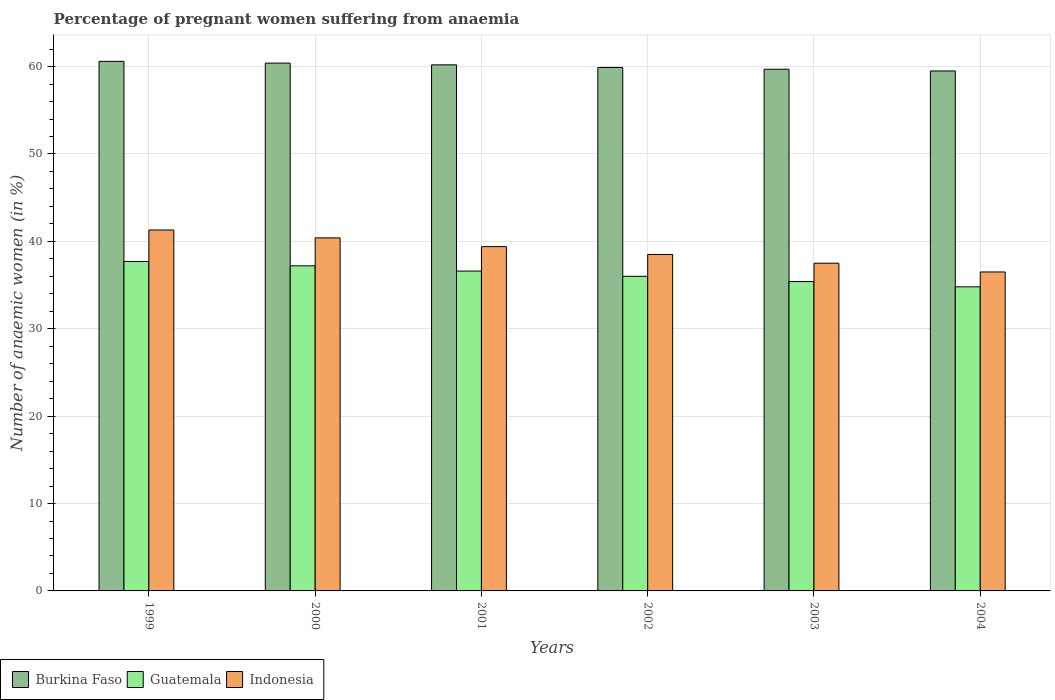Are the number of bars on each tick of the X-axis equal?
Your answer should be compact. Yes. How many bars are there on the 2nd tick from the left?
Offer a terse response. 3. How many bars are there on the 6th tick from the right?
Offer a terse response. 3. What is the number of anaemic women in Burkina Faso in 2000?
Offer a very short reply. 60.4. Across all years, what is the maximum number of anaemic women in Guatemala?
Ensure brevity in your answer.  37.7. Across all years, what is the minimum number of anaemic women in Indonesia?
Your answer should be compact. 36.5. What is the total number of anaemic women in Guatemala in the graph?
Provide a short and direct response. 217.7. What is the difference between the number of anaemic women in Burkina Faso in 2000 and that in 2003?
Provide a succinct answer. 0.7. What is the difference between the number of anaemic women in Indonesia in 2003 and the number of anaemic women in Guatemala in 2001?
Offer a very short reply. 0.9. What is the average number of anaemic women in Burkina Faso per year?
Your answer should be compact. 60.05. In the year 1999, what is the difference between the number of anaemic women in Guatemala and number of anaemic women in Indonesia?
Provide a succinct answer. -3.6. What is the ratio of the number of anaemic women in Guatemala in 1999 to that in 2004?
Your answer should be very brief. 1.08. What is the difference between the highest and the second highest number of anaemic women in Burkina Faso?
Your answer should be very brief. 0.2. What is the difference between the highest and the lowest number of anaemic women in Burkina Faso?
Your answer should be very brief. 1.1. Is the sum of the number of anaemic women in Burkina Faso in 1999 and 2004 greater than the maximum number of anaemic women in Guatemala across all years?
Your answer should be compact. Yes. What does the 2nd bar from the right in 2004 represents?
Your answer should be very brief. Guatemala. Does the graph contain any zero values?
Your answer should be very brief. No. Where does the legend appear in the graph?
Your response must be concise. Bottom left. What is the title of the graph?
Keep it short and to the point. Percentage of pregnant women suffering from anaemia. Does "Syrian Arab Republic" appear as one of the legend labels in the graph?
Provide a short and direct response. No. What is the label or title of the X-axis?
Your answer should be very brief. Years. What is the label or title of the Y-axis?
Offer a terse response. Number of anaemic women (in %). What is the Number of anaemic women (in %) of Burkina Faso in 1999?
Your response must be concise. 60.6. What is the Number of anaemic women (in %) of Guatemala in 1999?
Your answer should be very brief. 37.7. What is the Number of anaemic women (in %) of Indonesia in 1999?
Your answer should be compact. 41.3. What is the Number of anaemic women (in %) of Burkina Faso in 2000?
Your answer should be compact. 60.4. What is the Number of anaemic women (in %) in Guatemala in 2000?
Provide a short and direct response. 37.2. What is the Number of anaemic women (in %) of Indonesia in 2000?
Your response must be concise. 40.4. What is the Number of anaemic women (in %) in Burkina Faso in 2001?
Offer a very short reply. 60.2. What is the Number of anaemic women (in %) of Guatemala in 2001?
Provide a succinct answer. 36.6. What is the Number of anaemic women (in %) in Indonesia in 2001?
Your response must be concise. 39.4. What is the Number of anaemic women (in %) in Burkina Faso in 2002?
Offer a very short reply. 59.9. What is the Number of anaemic women (in %) in Guatemala in 2002?
Keep it short and to the point. 36. What is the Number of anaemic women (in %) of Indonesia in 2002?
Give a very brief answer. 38.5. What is the Number of anaemic women (in %) in Burkina Faso in 2003?
Your answer should be very brief. 59.7. What is the Number of anaemic women (in %) of Guatemala in 2003?
Provide a short and direct response. 35.4. What is the Number of anaemic women (in %) in Indonesia in 2003?
Your answer should be very brief. 37.5. What is the Number of anaemic women (in %) of Burkina Faso in 2004?
Your response must be concise. 59.5. What is the Number of anaemic women (in %) in Guatemala in 2004?
Make the answer very short. 34.8. What is the Number of anaemic women (in %) of Indonesia in 2004?
Your answer should be compact. 36.5. Across all years, what is the maximum Number of anaemic women (in %) of Burkina Faso?
Keep it short and to the point. 60.6. Across all years, what is the maximum Number of anaemic women (in %) of Guatemala?
Ensure brevity in your answer.  37.7. Across all years, what is the maximum Number of anaemic women (in %) of Indonesia?
Provide a short and direct response. 41.3. Across all years, what is the minimum Number of anaemic women (in %) of Burkina Faso?
Provide a succinct answer. 59.5. Across all years, what is the minimum Number of anaemic women (in %) in Guatemala?
Offer a terse response. 34.8. Across all years, what is the minimum Number of anaemic women (in %) of Indonesia?
Your answer should be very brief. 36.5. What is the total Number of anaemic women (in %) in Burkina Faso in the graph?
Give a very brief answer. 360.3. What is the total Number of anaemic women (in %) of Guatemala in the graph?
Your answer should be compact. 217.7. What is the total Number of anaemic women (in %) of Indonesia in the graph?
Your answer should be compact. 233.6. What is the difference between the Number of anaemic women (in %) in Burkina Faso in 1999 and that in 2000?
Give a very brief answer. 0.2. What is the difference between the Number of anaemic women (in %) of Indonesia in 1999 and that in 2000?
Make the answer very short. 0.9. What is the difference between the Number of anaemic women (in %) of Burkina Faso in 1999 and that in 2001?
Offer a terse response. 0.4. What is the difference between the Number of anaemic women (in %) of Indonesia in 1999 and that in 2001?
Make the answer very short. 1.9. What is the difference between the Number of anaemic women (in %) in Burkina Faso in 1999 and that in 2002?
Your answer should be very brief. 0.7. What is the difference between the Number of anaemic women (in %) in Guatemala in 1999 and that in 2002?
Provide a succinct answer. 1.7. What is the difference between the Number of anaemic women (in %) of Burkina Faso in 1999 and that in 2003?
Give a very brief answer. 0.9. What is the difference between the Number of anaemic women (in %) in Guatemala in 1999 and that in 2003?
Keep it short and to the point. 2.3. What is the difference between the Number of anaemic women (in %) in Indonesia in 1999 and that in 2003?
Provide a short and direct response. 3.8. What is the difference between the Number of anaemic women (in %) of Indonesia in 1999 and that in 2004?
Ensure brevity in your answer.  4.8. What is the difference between the Number of anaemic women (in %) in Burkina Faso in 2000 and that in 2001?
Give a very brief answer. 0.2. What is the difference between the Number of anaemic women (in %) in Burkina Faso in 2000 and that in 2002?
Offer a terse response. 0.5. What is the difference between the Number of anaemic women (in %) of Guatemala in 2000 and that in 2002?
Ensure brevity in your answer.  1.2. What is the difference between the Number of anaemic women (in %) in Burkina Faso in 2000 and that in 2003?
Provide a succinct answer. 0.7. What is the difference between the Number of anaemic women (in %) in Burkina Faso in 2000 and that in 2004?
Provide a short and direct response. 0.9. What is the difference between the Number of anaemic women (in %) of Guatemala in 2001 and that in 2002?
Your response must be concise. 0.6. What is the difference between the Number of anaemic women (in %) in Indonesia in 2001 and that in 2003?
Offer a terse response. 1.9. What is the difference between the Number of anaemic women (in %) of Guatemala in 2001 and that in 2004?
Provide a succinct answer. 1.8. What is the difference between the Number of anaemic women (in %) in Burkina Faso in 2002 and that in 2003?
Provide a succinct answer. 0.2. What is the difference between the Number of anaemic women (in %) of Indonesia in 2002 and that in 2003?
Your answer should be very brief. 1. What is the difference between the Number of anaemic women (in %) of Burkina Faso in 2002 and that in 2004?
Ensure brevity in your answer.  0.4. What is the difference between the Number of anaemic women (in %) in Burkina Faso in 2003 and that in 2004?
Keep it short and to the point. 0.2. What is the difference between the Number of anaemic women (in %) in Guatemala in 2003 and that in 2004?
Give a very brief answer. 0.6. What is the difference between the Number of anaemic women (in %) of Indonesia in 2003 and that in 2004?
Keep it short and to the point. 1. What is the difference between the Number of anaemic women (in %) in Burkina Faso in 1999 and the Number of anaemic women (in %) in Guatemala in 2000?
Provide a short and direct response. 23.4. What is the difference between the Number of anaemic women (in %) of Burkina Faso in 1999 and the Number of anaemic women (in %) of Indonesia in 2000?
Keep it short and to the point. 20.2. What is the difference between the Number of anaemic women (in %) in Burkina Faso in 1999 and the Number of anaemic women (in %) in Guatemala in 2001?
Ensure brevity in your answer.  24. What is the difference between the Number of anaemic women (in %) in Burkina Faso in 1999 and the Number of anaemic women (in %) in Indonesia in 2001?
Offer a very short reply. 21.2. What is the difference between the Number of anaemic women (in %) in Burkina Faso in 1999 and the Number of anaemic women (in %) in Guatemala in 2002?
Offer a terse response. 24.6. What is the difference between the Number of anaemic women (in %) of Burkina Faso in 1999 and the Number of anaemic women (in %) of Indonesia in 2002?
Your answer should be very brief. 22.1. What is the difference between the Number of anaemic women (in %) of Guatemala in 1999 and the Number of anaemic women (in %) of Indonesia in 2002?
Ensure brevity in your answer.  -0.8. What is the difference between the Number of anaemic women (in %) in Burkina Faso in 1999 and the Number of anaemic women (in %) in Guatemala in 2003?
Ensure brevity in your answer.  25.2. What is the difference between the Number of anaemic women (in %) in Burkina Faso in 1999 and the Number of anaemic women (in %) in Indonesia in 2003?
Your answer should be compact. 23.1. What is the difference between the Number of anaemic women (in %) of Burkina Faso in 1999 and the Number of anaemic women (in %) of Guatemala in 2004?
Offer a terse response. 25.8. What is the difference between the Number of anaemic women (in %) of Burkina Faso in 1999 and the Number of anaemic women (in %) of Indonesia in 2004?
Ensure brevity in your answer.  24.1. What is the difference between the Number of anaemic women (in %) in Burkina Faso in 2000 and the Number of anaemic women (in %) in Guatemala in 2001?
Your answer should be compact. 23.8. What is the difference between the Number of anaemic women (in %) of Guatemala in 2000 and the Number of anaemic women (in %) of Indonesia in 2001?
Provide a succinct answer. -2.2. What is the difference between the Number of anaemic women (in %) of Burkina Faso in 2000 and the Number of anaemic women (in %) of Guatemala in 2002?
Make the answer very short. 24.4. What is the difference between the Number of anaemic women (in %) in Burkina Faso in 2000 and the Number of anaemic women (in %) in Indonesia in 2002?
Offer a very short reply. 21.9. What is the difference between the Number of anaemic women (in %) in Guatemala in 2000 and the Number of anaemic women (in %) in Indonesia in 2002?
Make the answer very short. -1.3. What is the difference between the Number of anaemic women (in %) in Burkina Faso in 2000 and the Number of anaemic women (in %) in Indonesia in 2003?
Give a very brief answer. 22.9. What is the difference between the Number of anaemic women (in %) in Guatemala in 2000 and the Number of anaemic women (in %) in Indonesia in 2003?
Your response must be concise. -0.3. What is the difference between the Number of anaemic women (in %) of Burkina Faso in 2000 and the Number of anaemic women (in %) of Guatemala in 2004?
Provide a short and direct response. 25.6. What is the difference between the Number of anaemic women (in %) in Burkina Faso in 2000 and the Number of anaemic women (in %) in Indonesia in 2004?
Provide a short and direct response. 23.9. What is the difference between the Number of anaemic women (in %) of Guatemala in 2000 and the Number of anaemic women (in %) of Indonesia in 2004?
Your response must be concise. 0.7. What is the difference between the Number of anaemic women (in %) of Burkina Faso in 2001 and the Number of anaemic women (in %) of Guatemala in 2002?
Your answer should be compact. 24.2. What is the difference between the Number of anaemic women (in %) in Burkina Faso in 2001 and the Number of anaemic women (in %) in Indonesia in 2002?
Your answer should be compact. 21.7. What is the difference between the Number of anaemic women (in %) of Guatemala in 2001 and the Number of anaemic women (in %) of Indonesia in 2002?
Make the answer very short. -1.9. What is the difference between the Number of anaemic women (in %) of Burkina Faso in 2001 and the Number of anaemic women (in %) of Guatemala in 2003?
Your answer should be very brief. 24.8. What is the difference between the Number of anaemic women (in %) in Burkina Faso in 2001 and the Number of anaemic women (in %) in Indonesia in 2003?
Provide a succinct answer. 22.7. What is the difference between the Number of anaemic women (in %) of Burkina Faso in 2001 and the Number of anaemic women (in %) of Guatemala in 2004?
Offer a very short reply. 25.4. What is the difference between the Number of anaemic women (in %) of Burkina Faso in 2001 and the Number of anaemic women (in %) of Indonesia in 2004?
Your answer should be compact. 23.7. What is the difference between the Number of anaemic women (in %) in Burkina Faso in 2002 and the Number of anaemic women (in %) in Guatemala in 2003?
Make the answer very short. 24.5. What is the difference between the Number of anaemic women (in %) of Burkina Faso in 2002 and the Number of anaemic women (in %) of Indonesia in 2003?
Your response must be concise. 22.4. What is the difference between the Number of anaemic women (in %) in Guatemala in 2002 and the Number of anaemic women (in %) in Indonesia in 2003?
Make the answer very short. -1.5. What is the difference between the Number of anaemic women (in %) of Burkina Faso in 2002 and the Number of anaemic women (in %) of Guatemala in 2004?
Give a very brief answer. 25.1. What is the difference between the Number of anaemic women (in %) in Burkina Faso in 2002 and the Number of anaemic women (in %) in Indonesia in 2004?
Ensure brevity in your answer.  23.4. What is the difference between the Number of anaemic women (in %) in Guatemala in 2002 and the Number of anaemic women (in %) in Indonesia in 2004?
Your response must be concise. -0.5. What is the difference between the Number of anaemic women (in %) in Burkina Faso in 2003 and the Number of anaemic women (in %) in Guatemala in 2004?
Provide a succinct answer. 24.9. What is the difference between the Number of anaemic women (in %) in Burkina Faso in 2003 and the Number of anaemic women (in %) in Indonesia in 2004?
Offer a terse response. 23.2. What is the difference between the Number of anaemic women (in %) of Guatemala in 2003 and the Number of anaemic women (in %) of Indonesia in 2004?
Give a very brief answer. -1.1. What is the average Number of anaemic women (in %) in Burkina Faso per year?
Your response must be concise. 60.05. What is the average Number of anaemic women (in %) of Guatemala per year?
Offer a very short reply. 36.28. What is the average Number of anaemic women (in %) of Indonesia per year?
Your answer should be compact. 38.93. In the year 1999, what is the difference between the Number of anaemic women (in %) in Burkina Faso and Number of anaemic women (in %) in Guatemala?
Give a very brief answer. 22.9. In the year 1999, what is the difference between the Number of anaemic women (in %) of Burkina Faso and Number of anaemic women (in %) of Indonesia?
Make the answer very short. 19.3. In the year 2000, what is the difference between the Number of anaemic women (in %) in Burkina Faso and Number of anaemic women (in %) in Guatemala?
Provide a succinct answer. 23.2. In the year 2000, what is the difference between the Number of anaemic women (in %) of Guatemala and Number of anaemic women (in %) of Indonesia?
Make the answer very short. -3.2. In the year 2001, what is the difference between the Number of anaemic women (in %) of Burkina Faso and Number of anaemic women (in %) of Guatemala?
Offer a terse response. 23.6. In the year 2001, what is the difference between the Number of anaemic women (in %) in Burkina Faso and Number of anaemic women (in %) in Indonesia?
Offer a terse response. 20.8. In the year 2001, what is the difference between the Number of anaemic women (in %) of Guatemala and Number of anaemic women (in %) of Indonesia?
Keep it short and to the point. -2.8. In the year 2002, what is the difference between the Number of anaemic women (in %) of Burkina Faso and Number of anaemic women (in %) of Guatemala?
Offer a terse response. 23.9. In the year 2002, what is the difference between the Number of anaemic women (in %) of Burkina Faso and Number of anaemic women (in %) of Indonesia?
Provide a short and direct response. 21.4. In the year 2002, what is the difference between the Number of anaemic women (in %) of Guatemala and Number of anaemic women (in %) of Indonesia?
Give a very brief answer. -2.5. In the year 2003, what is the difference between the Number of anaemic women (in %) of Burkina Faso and Number of anaemic women (in %) of Guatemala?
Make the answer very short. 24.3. In the year 2003, what is the difference between the Number of anaemic women (in %) of Guatemala and Number of anaemic women (in %) of Indonesia?
Provide a short and direct response. -2.1. In the year 2004, what is the difference between the Number of anaemic women (in %) of Burkina Faso and Number of anaemic women (in %) of Guatemala?
Give a very brief answer. 24.7. In the year 2004, what is the difference between the Number of anaemic women (in %) in Burkina Faso and Number of anaemic women (in %) in Indonesia?
Make the answer very short. 23. What is the ratio of the Number of anaemic women (in %) of Burkina Faso in 1999 to that in 2000?
Provide a short and direct response. 1. What is the ratio of the Number of anaemic women (in %) in Guatemala in 1999 to that in 2000?
Offer a terse response. 1.01. What is the ratio of the Number of anaemic women (in %) of Indonesia in 1999 to that in 2000?
Offer a terse response. 1.02. What is the ratio of the Number of anaemic women (in %) in Burkina Faso in 1999 to that in 2001?
Ensure brevity in your answer.  1.01. What is the ratio of the Number of anaemic women (in %) of Guatemala in 1999 to that in 2001?
Offer a terse response. 1.03. What is the ratio of the Number of anaemic women (in %) of Indonesia in 1999 to that in 2001?
Offer a very short reply. 1.05. What is the ratio of the Number of anaemic women (in %) of Burkina Faso in 1999 to that in 2002?
Your response must be concise. 1.01. What is the ratio of the Number of anaemic women (in %) of Guatemala in 1999 to that in 2002?
Provide a short and direct response. 1.05. What is the ratio of the Number of anaemic women (in %) of Indonesia in 1999 to that in 2002?
Your response must be concise. 1.07. What is the ratio of the Number of anaemic women (in %) in Burkina Faso in 1999 to that in 2003?
Your answer should be very brief. 1.02. What is the ratio of the Number of anaemic women (in %) of Guatemala in 1999 to that in 2003?
Your answer should be compact. 1.06. What is the ratio of the Number of anaemic women (in %) in Indonesia in 1999 to that in 2003?
Make the answer very short. 1.1. What is the ratio of the Number of anaemic women (in %) of Burkina Faso in 1999 to that in 2004?
Provide a short and direct response. 1.02. What is the ratio of the Number of anaemic women (in %) of Guatemala in 1999 to that in 2004?
Your answer should be compact. 1.08. What is the ratio of the Number of anaemic women (in %) in Indonesia in 1999 to that in 2004?
Offer a very short reply. 1.13. What is the ratio of the Number of anaemic women (in %) in Guatemala in 2000 to that in 2001?
Make the answer very short. 1.02. What is the ratio of the Number of anaemic women (in %) of Indonesia in 2000 to that in 2001?
Provide a short and direct response. 1.03. What is the ratio of the Number of anaemic women (in %) in Burkina Faso in 2000 to that in 2002?
Provide a succinct answer. 1.01. What is the ratio of the Number of anaemic women (in %) in Guatemala in 2000 to that in 2002?
Your response must be concise. 1.03. What is the ratio of the Number of anaemic women (in %) in Indonesia in 2000 to that in 2002?
Make the answer very short. 1.05. What is the ratio of the Number of anaemic women (in %) of Burkina Faso in 2000 to that in 2003?
Your answer should be compact. 1.01. What is the ratio of the Number of anaemic women (in %) in Guatemala in 2000 to that in 2003?
Give a very brief answer. 1.05. What is the ratio of the Number of anaemic women (in %) of Indonesia in 2000 to that in 2003?
Offer a very short reply. 1.08. What is the ratio of the Number of anaemic women (in %) in Burkina Faso in 2000 to that in 2004?
Your response must be concise. 1.02. What is the ratio of the Number of anaemic women (in %) of Guatemala in 2000 to that in 2004?
Your response must be concise. 1.07. What is the ratio of the Number of anaemic women (in %) of Indonesia in 2000 to that in 2004?
Offer a very short reply. 1.11. What is the ratio of the Number of anaemic women (in %) in Burkina Faso in 2001 to that in 2002?
Provide a short and direct response. 1. What is the ratio of the Number of anaemic women (in %) of Guatemala in 2001 to that in 2002?
Offer a terse response. 1.02. What is the ratio of the Number of anaemic women (in %) in Indonesia in 2001 to that in 2002?
Give a very brief answer. 1.02. What is the ratio of the Number of anaemic women (in %) of Burkina Faso in 2001 to that in 2003?
Ensure brevity in your answer.  1.01. What is the ratio of the Number of anaemic women (in %) in Guatemala in 2001 to that in 2003?
Keep it short and to the point. 1.03. What is the ratio of the Number of anaemic women (in %) in Indonesia in 2001 to that in 2003?
Offer a terse response. 1.05. What is the ratio of the Number of anaemic women (in %) in Burkina Faso in 2001 to that in 2004?
Offer a very short reply. 1.01. What is the ratio of the Number of anaemic women (in %) in Guatemala in 2001 to that in 2004?
Offer a very short reply. 1.05. What is the ratio of the Number of anaemic women (in %) in Indonesia in 2001 to that in 2004?
Your answer should be very brief. 1.08. What is the ratio of the Number of anaemic women (in %) of Guatemala in 2002 to that in 2003?
Your response must be concise. 1.02. What is the ratio of the Number of anaemic women (in %) of Indonesia in 2002 to that in 2003?
Ensure brevity in your answer.  1.03. What is the ratio of the Number of anaemic women (in %) in Burkina Faso in 2002 to that in 2004?
Your response must be concise. 1.01. What is the ratio of the Number of anaemic women (in %) in Guatemala in 2002 to that in 2004?
Offer a very short reply. 1.03. What is the ratio of the Number of anaemic women (in %) of Indonesia in 2002 to that in 2004?
Give a very brief answer. 1.05. What is the ratio of the Number of anaemic women (in %) in Guatemala in 2003 to that in 2004?
Offer a very short reply. 1.02. What is the ratio of the Number of anaemic women (in %) in Indonesia in 2003 to that in 2004?
Your answer should be compact. 1.03. What is the difference between the highest and the second highest Number of anaemic women (in %) of Burkina Faso?
Your response must be concise. 0.2. What is the difference between the highest and the second highest Number of anaemic women (in %) of Indonesia?
Your answer should be very brief. 0.9. What is the difference between the highest and the lowest Number of anaemic women (in %) of Burkina Faso?
Offer a terse response. 1.1. 